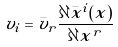<formula> <loc_0><loc_0><loc_500><loc_500>v _ { i } = { \bar { v } } _ { r } { \frac { \partial { \bar { x } } ^ { i } ( x ) } { \partial x ^ { r } } }</formula> 